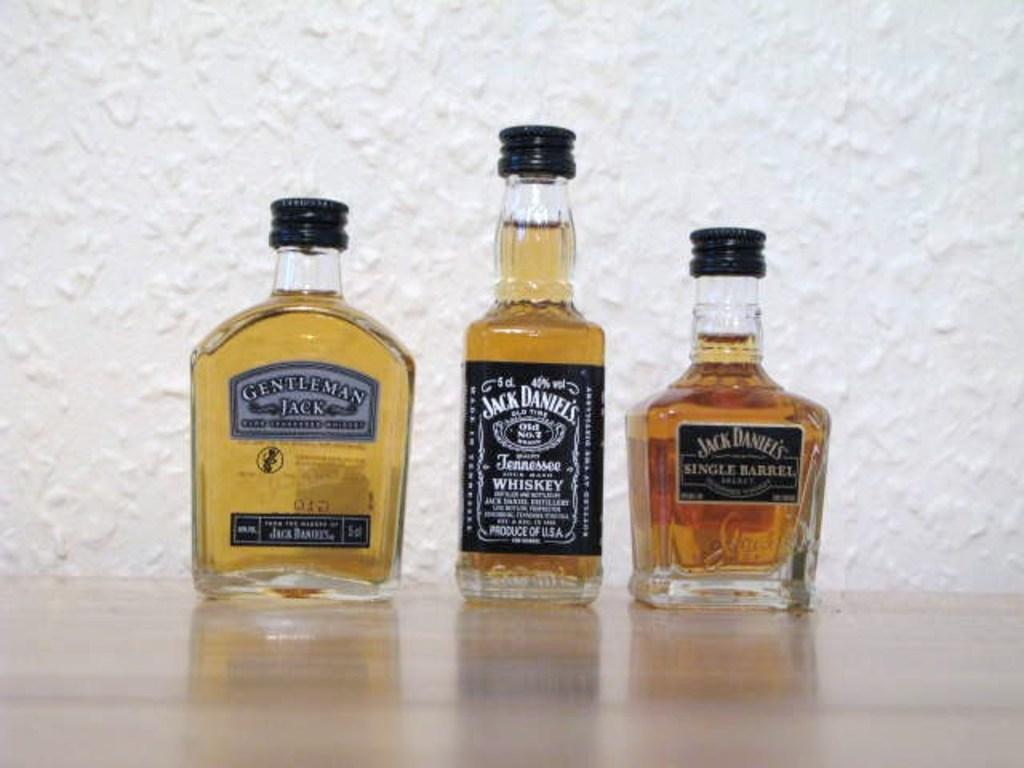What brand of whiskey is the middle one?
Give a very brief answer. Jack daniels. 